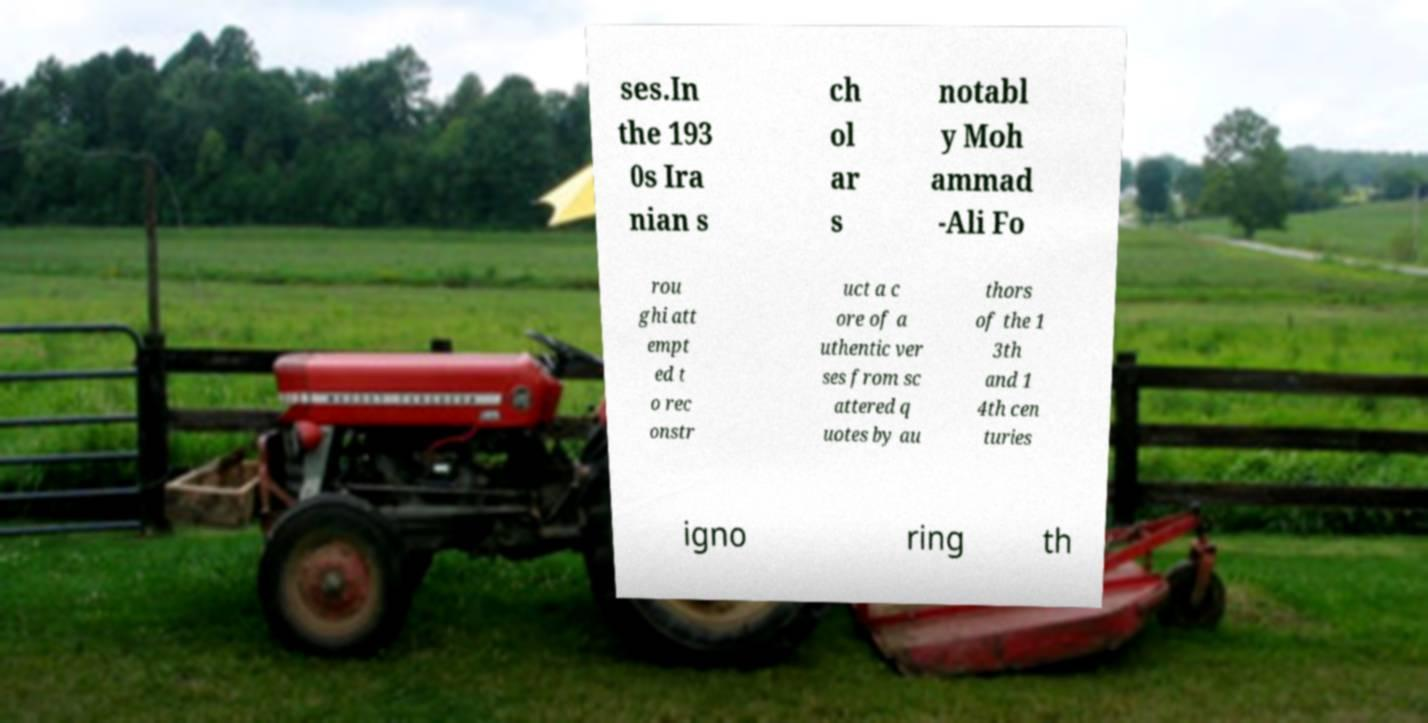Could you extract and type out the text from this image? ses.In the 193 0s Ira nian s ch ol ar s notabl y Moh ammad -Ali Fo rou ghi att empt ed t o rec onstr uct a c ore of a uthentic ver ses from sc attered q uotes by au thors of the 1 3th and 1 4th cen turies igno ring th 